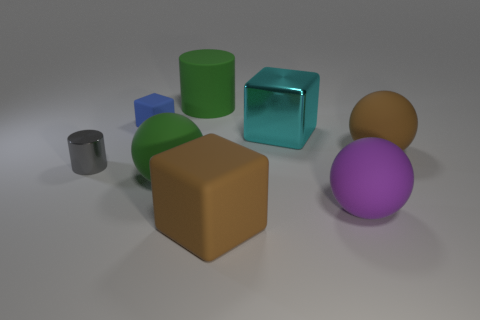Add 1 green shiny cylinders. How many objects exist? 9 Subtract all cubes. How many objects are left? 5 Add 7 green rubber objects. How many green rubber objects are left? 9 Add 4 small brown shiny balls. How many small brown shiny balls exist? 4 Subtract 0 gray spheres. How many objects are left? 8 Subtract all big rubber cylinders. Subtract all brown rubber cubes. How many objects are left? 6 